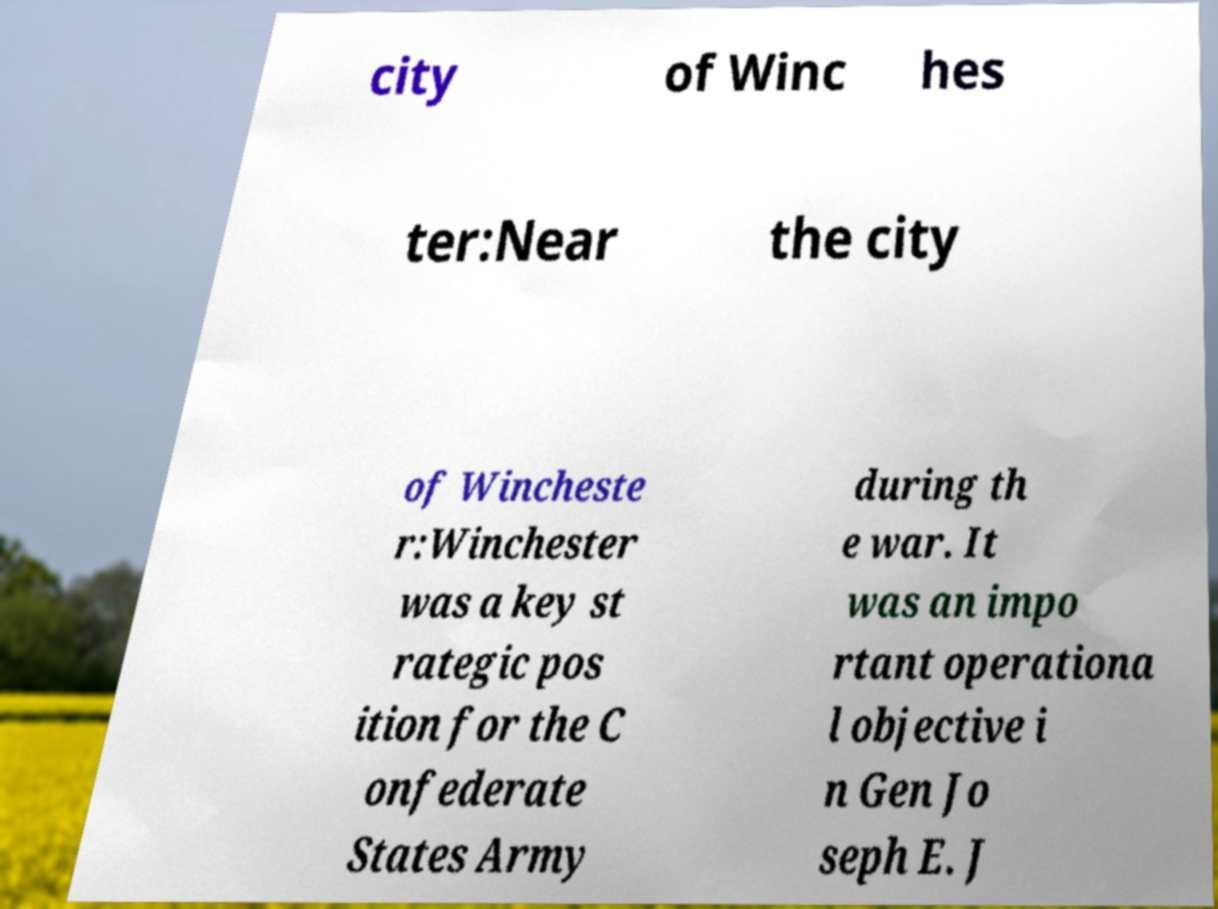Can you read and provide the text displayed in the image?This photo seems to have some interesting text. Can you extract and type it out for me? city of Winc hes ter:Near the city of Wincheste r:Winchester was a key st rategic pos ition for the C onfederate States Army during th e war. It was an impo rtant operationa l objective i n Gen Jo seph E. J 